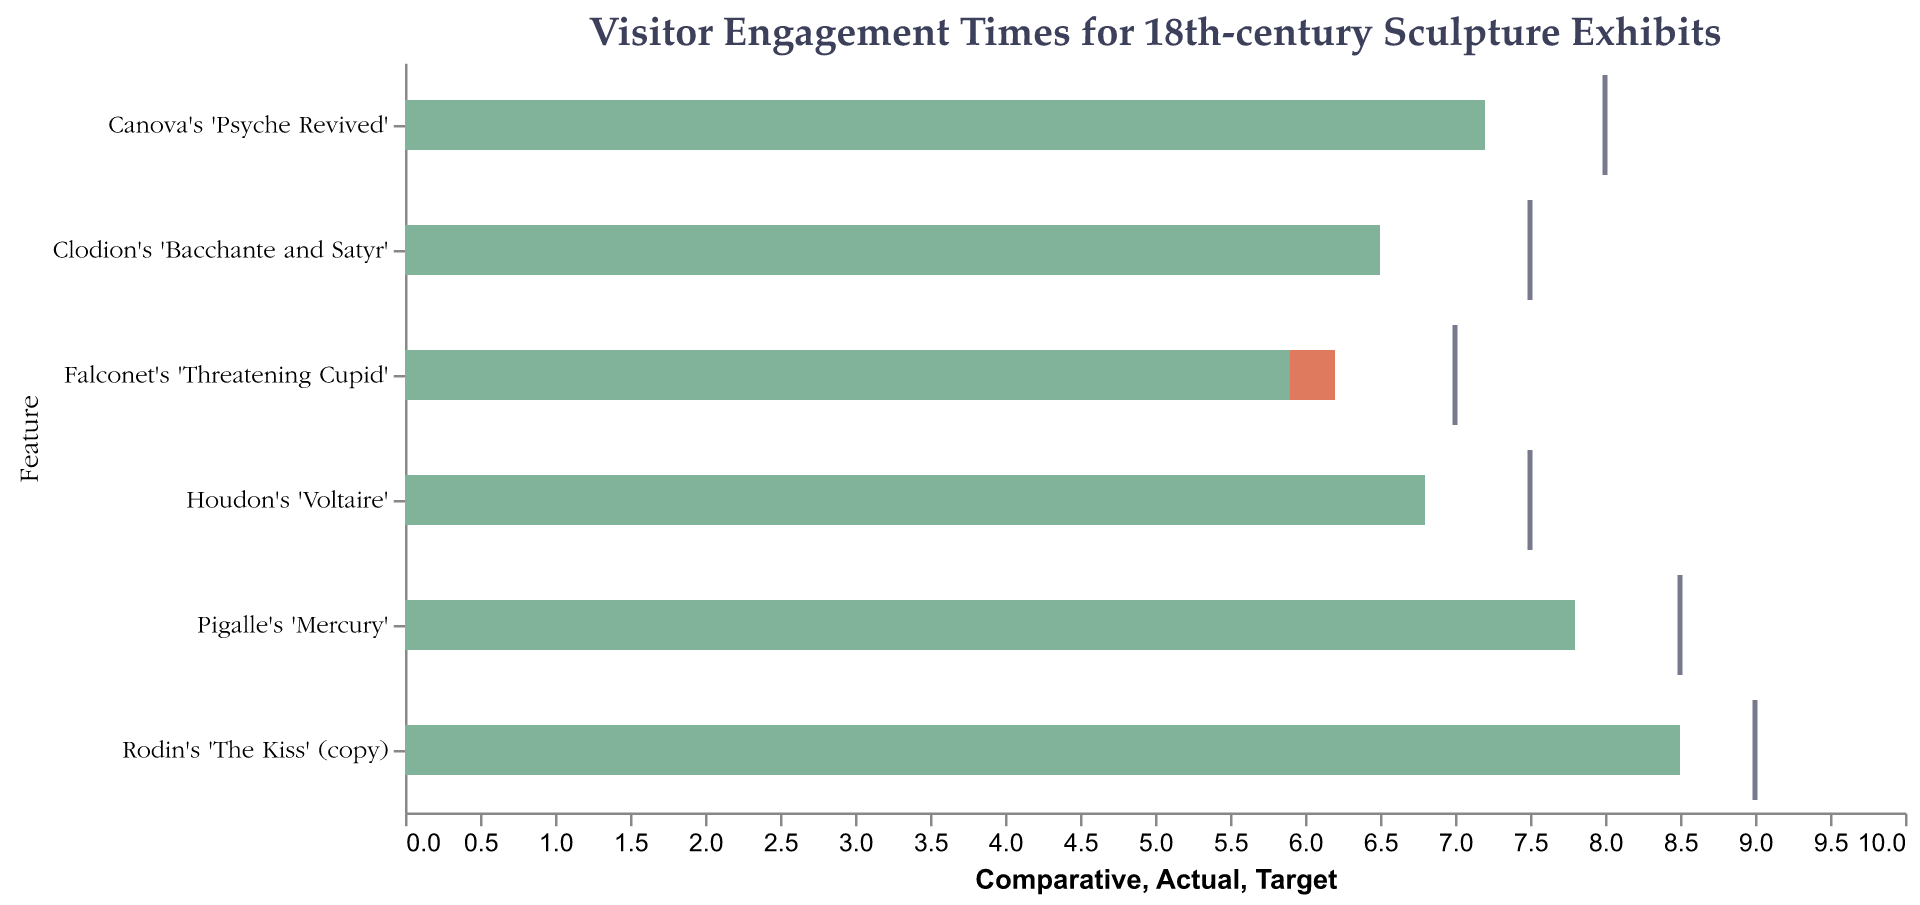What is the title of the chart? The title is usually the text at the top center in larger font size. Here, it is "Visitor Engagement Times for 18th-century Sculpture Exhibits".
Answer: Visitor Engagement Times for 18th-century Sculpture Exhibits Which sculpture had the highest actual visitor engagement time? By looking at the height of the green bars in the figure, "Rodin's 'The Kiss' (copy)" has the highest actual visitor engagement time of 8.5 minutes.
Answer: Rodin's 'The Kiss' (copy) How does the actual visitor engagement time for Falconet's 'Threatening Cupid' compare to its comparative and target times? For "Falconet's 'Threatening Cupid'", the actual time is 5.9 minutes, the comparative time is 6.2 minutes, and the target time is 7 minutes. Thus, the actual time is less than both the comparative and target times.
Answer: Less than both Which sculpture's visitor engagement time exceeds its comparative time, but falls short of its target time? By comparing the bars and the ticks for each sculpture, "Canova's 'Psyche Revived'" has an actual time of 7.2 minutes, which is greater than its comparative time of 6.2 minutes but less than its target time of 8 minutes.
Answer: Canova's 'Psyche Revived' Calculate the difference between the actual and target visitor engagement times for "Clodion's 'Bacchante and Satyr'". The actual time for "Clodion's 'Bacchante and Satyr'" is 6.5 minutes, and the target time is 7.5 minutes. The difference is 7.5 - 6.5 = 1 minute.
Answer: 1 minute How many sculptures have actual engagement times less than their comparative times? By comparing the heights of the green bars (actual times) against the red bars (comparative times), we see that only "Falconet's 'Threatening Cupid'" has an actual time (5.9 minutes) less than its comparative time (6.2 minutes).
Answer: 1 sculpture Which sculpture has the smallest difference between its actual and target visitor engagement times? By calculating the differences between the actual and target times for each sculpture:  
- Rodin: 9 - 8.5 = 0.5  
- Canova: 8 - 7.2 = 0.8  
- Houdon: 7.5 - 6.8 = 0.7  
- Falconet: 7 - 5.9 = 1.1  
- Clodion: 7.5 - 6.5 = 1  
- Pigalle: 8.5 - 7.8 = 0.7  
The smallest difference is for "Rodin's 'The Kiss' (copy)" with a difference of 0.5.
Answer: Rodin's 'The Kiss' (copy) What is the average actual engagement time across all sculptures? Adding the actual times (8.5 + 7.2 + 6.8 + 5.9 + 6.5 + 7.8) and dividing by the number of sculptures (6), we get (42.7 / 6) = 7.12 minutes.
Answer: 7.12 minutes 